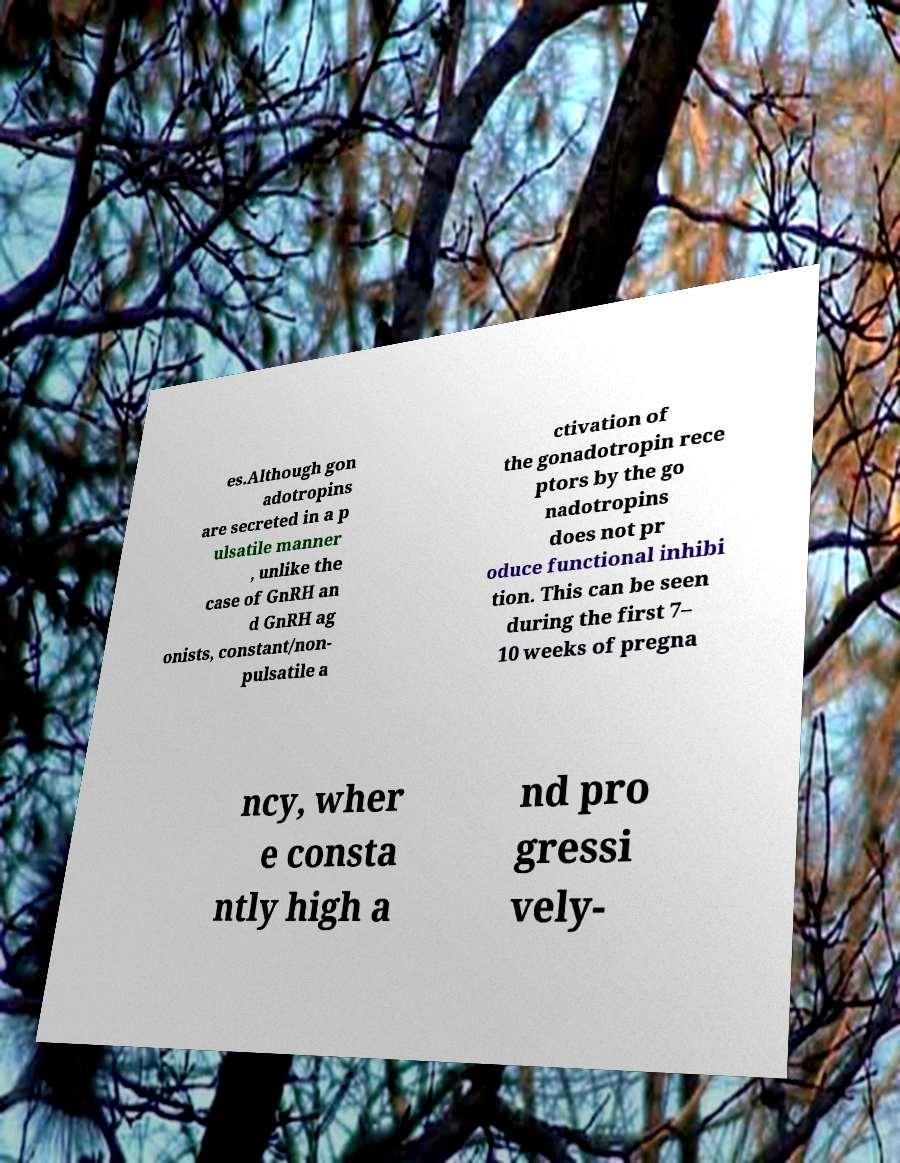Can you read and provide the text displayed in the image?This photo seems to have some interesting text. Can you extract and type it out for me? es.Although gon adotropins are secreted in a p ulsatile manner , unlike the case of GnRH an d GnRH ag onists, constant/non- pulsatile a ctivation of the gonadotropin rece ptors by the go nadotropins does not pr oduce functional inhibi tion. This can be seen during the first 7– 10 weeks of pregna ncy, wher e consta ntly high a nd pro gressi vely- 